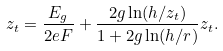Convert formula to latex. <formula><loc_0><loc_0><loc_500><loc_500>z _ { t } = \frac { E _ { g } } { 2 e F } + \frac { 2 g \ln ( h / z _ { t } ) } { 1 + 2 g \ln ( h / r ) } z _ { t } .</formula> 